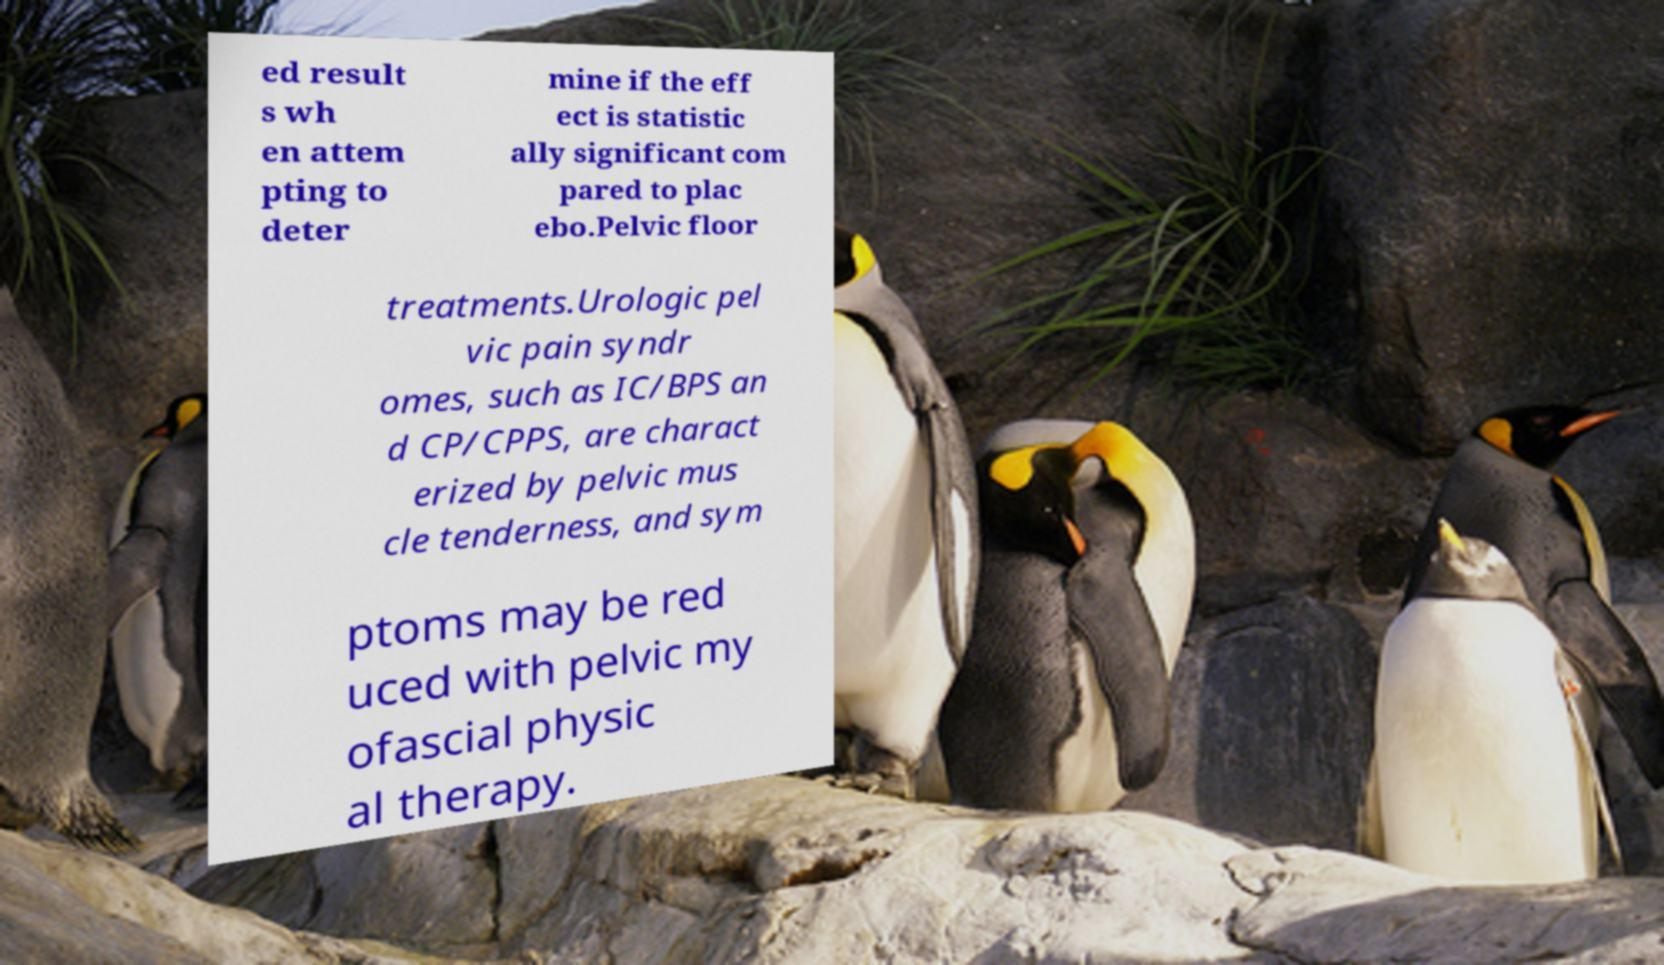Could you assist in decoding the text presented in this image and type it out clearly? ed result s wh en attem pting to deter mine if the eff ect is statistic ally significant com pared to plac ebo.Pelvic floor treatments.Urologic pel vic pain syndr omes, such as IC/BPS an d CP/CPPS, are charact erized by pelvic mus cle tenderness, and sym ptoms may be red uced with pelvic my ofascial physic al therapy. 